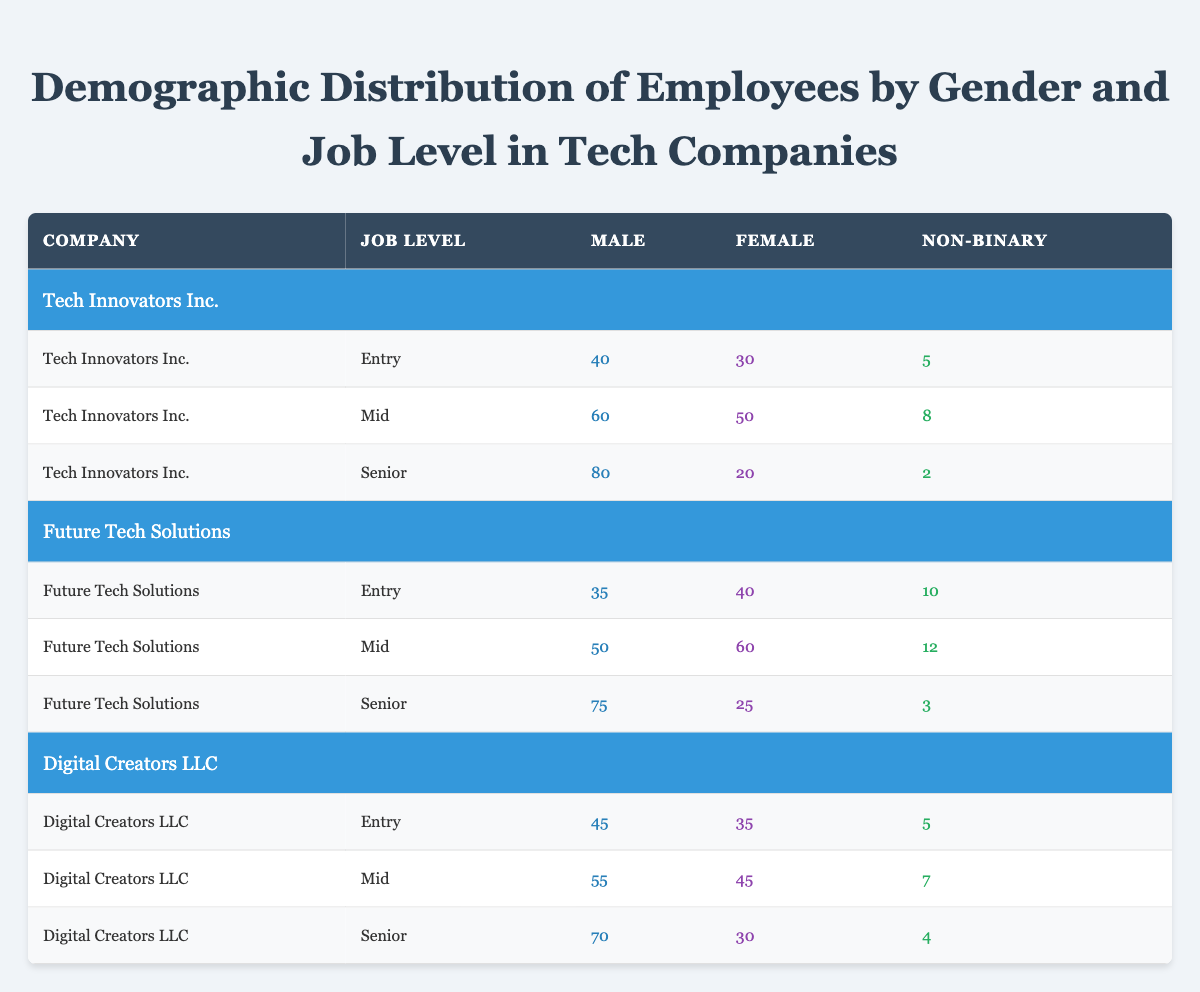What is the total number of male employees at Tech Innovators Inc. in the Mid job level? The data for Tech Innovators Inc. at the Mid job level shows that there are 60 male employees. This value can be found directly in the table under the Male column for the corresponding Company and Job Level.
Answer: 60 What is the difference in the number of non-binary employees between the Entry and Senior levels at Future Tech Solutions? For Future Tech Solutions, in the Entry level, there are 10 non-binary employees, and in the Senior level, there are 3 non-binary employees. The difference can be calculated as 10 - 3 = 7.
Answer: 7 Which company has the highest number of female employees at the Senior level? The table displays the female employee numbers for each company at the Senior level: Tech Innovators Inc. has 20, Future Tech Solutions has 25, and Digital Creators LLC has 30. Digital Creators LLC has the highest number, as 30 is greater than both 20 and 25.
Answer: Digital Creators LLC Is there a non-binary employee at Tech Innovators Inc. in the Senior level? According to the data provided, Tech Innovators Inc. has 2 non-binary employees at the Senior level. Since this is a defined value greater than zero, the answer is yes.
Answer: Yes What is the average number of female employees across all companies in the Mid job level? To calculate the average number of female employees in the Mid job level across all companies, first, sum the number of female employees: Tech Innovators Inc. has 50, Future Tech Solutions has 60, and Digital Creators LLC has 45. This gives us 50 + 60 + 45 = 155. Since there are 3 companies, we divide 155 by 3, resulting in approximately 51.67.
Answer: 51.67 